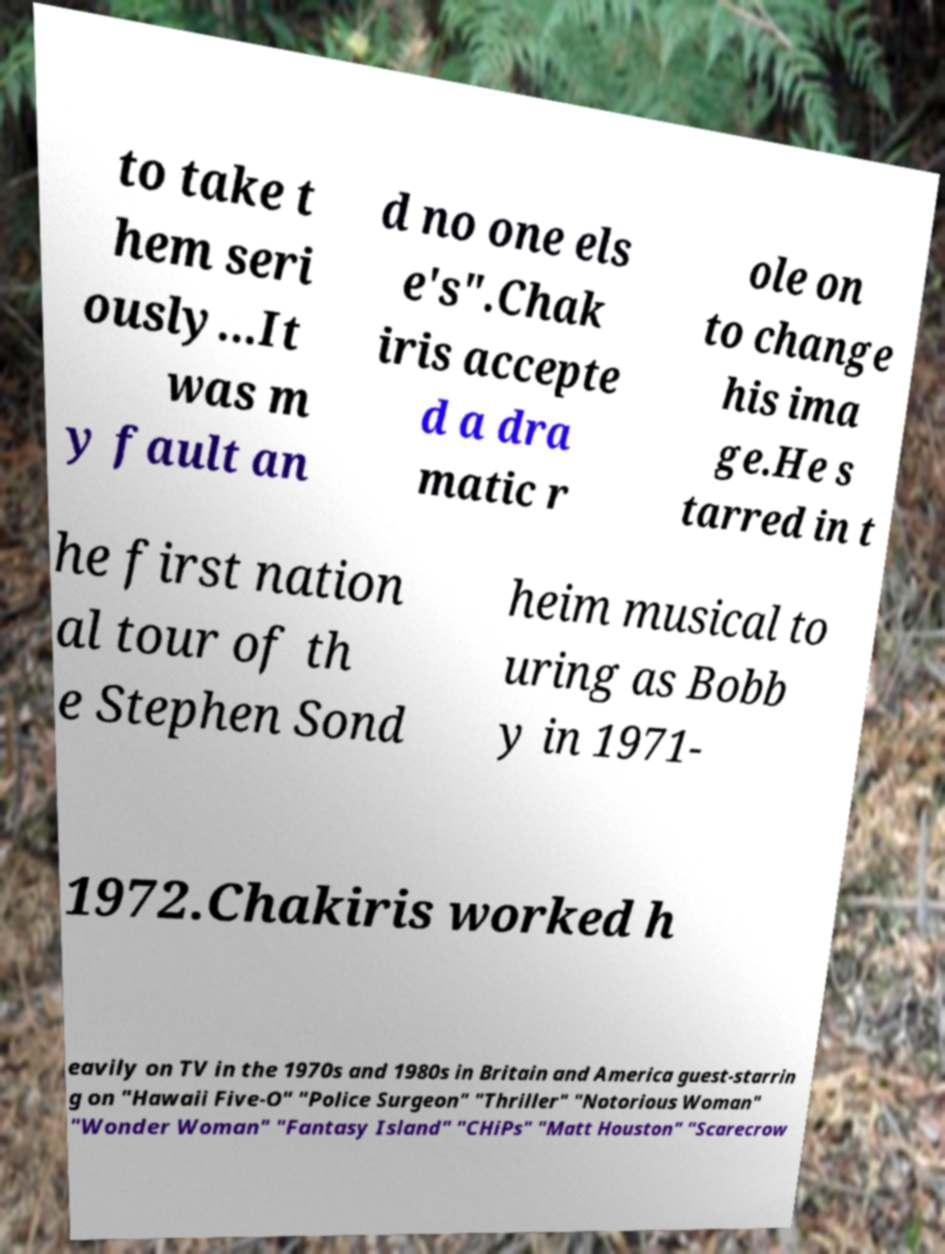I need the written content from this picture converted into text. Can you do that? to take t hem seri ously...It was m y fault an d no one els e's".Chak iris accepte d a dra matic r ole on to change his ima ge.He s tarred in t he first nation al tour of th e Stephen Sond heim musical to uring as Bobb y in 1971- 1972.Chakiris worked h eavily on TV in the 1970s and 1980s in Britain and America guest-starrin g on "Hawaii Five-O" "Police Surgeon" "Thriller" "Notorious Woman" "Wonder Woman" "Fantasy Island" "CHiPs" "Matt Houston" "Scarecrow 